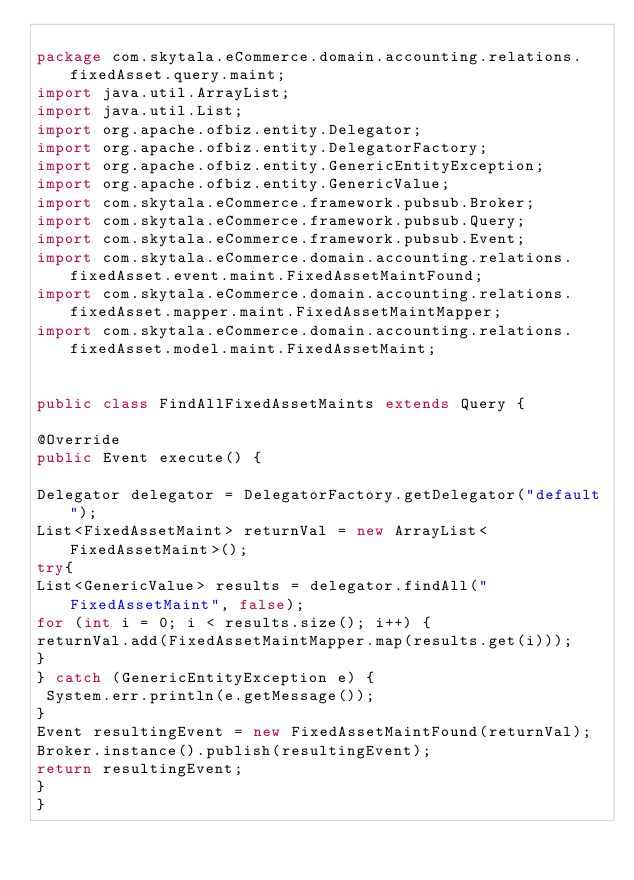<code> <loc_0><loc_0><loc_500><loc_500><_Java_>
package com.skytala.eCommerce.domain.accounting.relations.fixedAsset.query.maint;
import java.util.ArrayList;
import java.util.List;
import org.apache.ofbiz.entity.Delegator;
import org.apache.ofbiz.entity.DelegatorFactory;
import org.apache.ofbiz.entity.GenericEntityException;
import org.apache.ofbiz.entity.GenericValue;
import com.skytala.eCommerce.framework.pubsub.Broker;
import com.skytala.eCommerce.framework.pubsub.Query;
import com.skytala.eCommerce.framework.pubsub.Event;
import com.skytala.eCommerce.domain.accounting.relations.fixedAsset.event.maint.FixedAssetMaintFound;
import com.skytala.eCommerce.domain.accounting.relations.fixedAsset.mapper.maint.FixedAssetMaintMapper;
import com.skytala.eCommerce.domain.accounting.relations.fixedAsset.model.maint.FixedAssetMaint;


public class FindAllFixedAssetMaints extends Query {

@Override
public Event execute() {

Delegator delegator = DelegatorFactory.getDelegator("default");
List<FixedAssetMaint> returnVal = new ArrayList<FixedAssetMaint>();
try{
List<GenericValue> results = delegator.findAll("FixedAssetMaint", false);
for (int i = 0; i < results.size(); i++) {
returnVal.add(FixedAssetMaintMapper.map(results.get(i)));
}
} catch (GenericEntityException e) {
 System.err.println(e.getMessage()); 
}
Event resultingEvent = new FixedAssetMaintFound(returnVal);
Broker.instance().publish(resultingEvent);
return resultingEvent;
}
}
</code> 